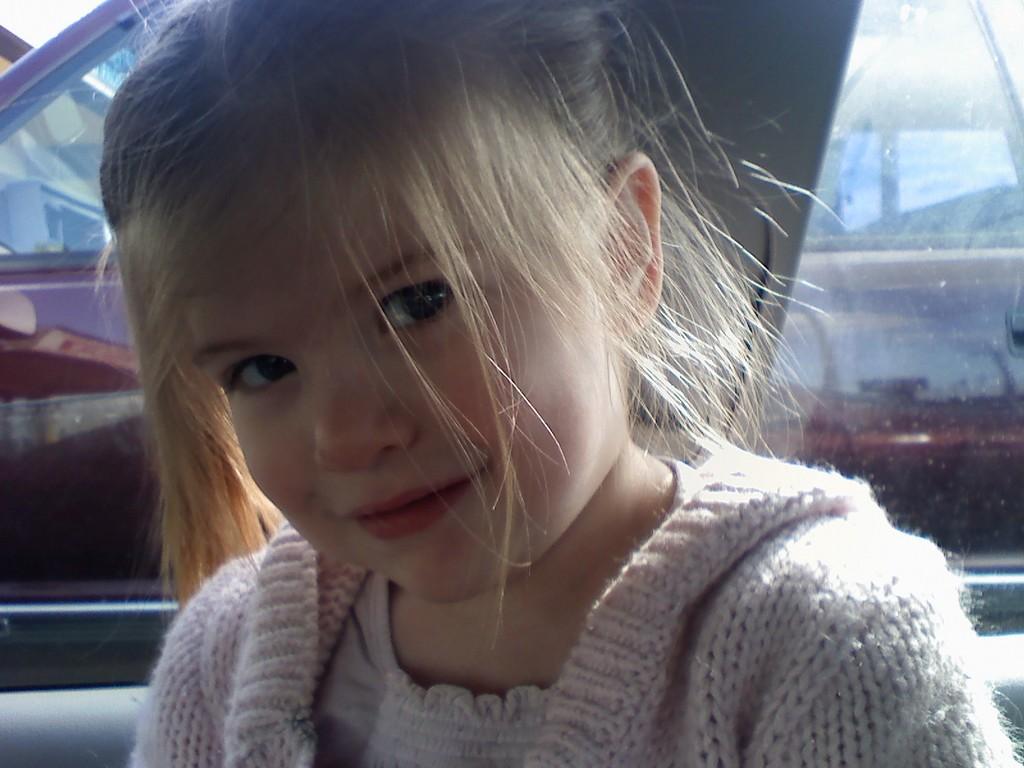Please provide a concise description of this image. In the image there is a girl inside a car. Behind her there is a car window. Behind that there is a car.  